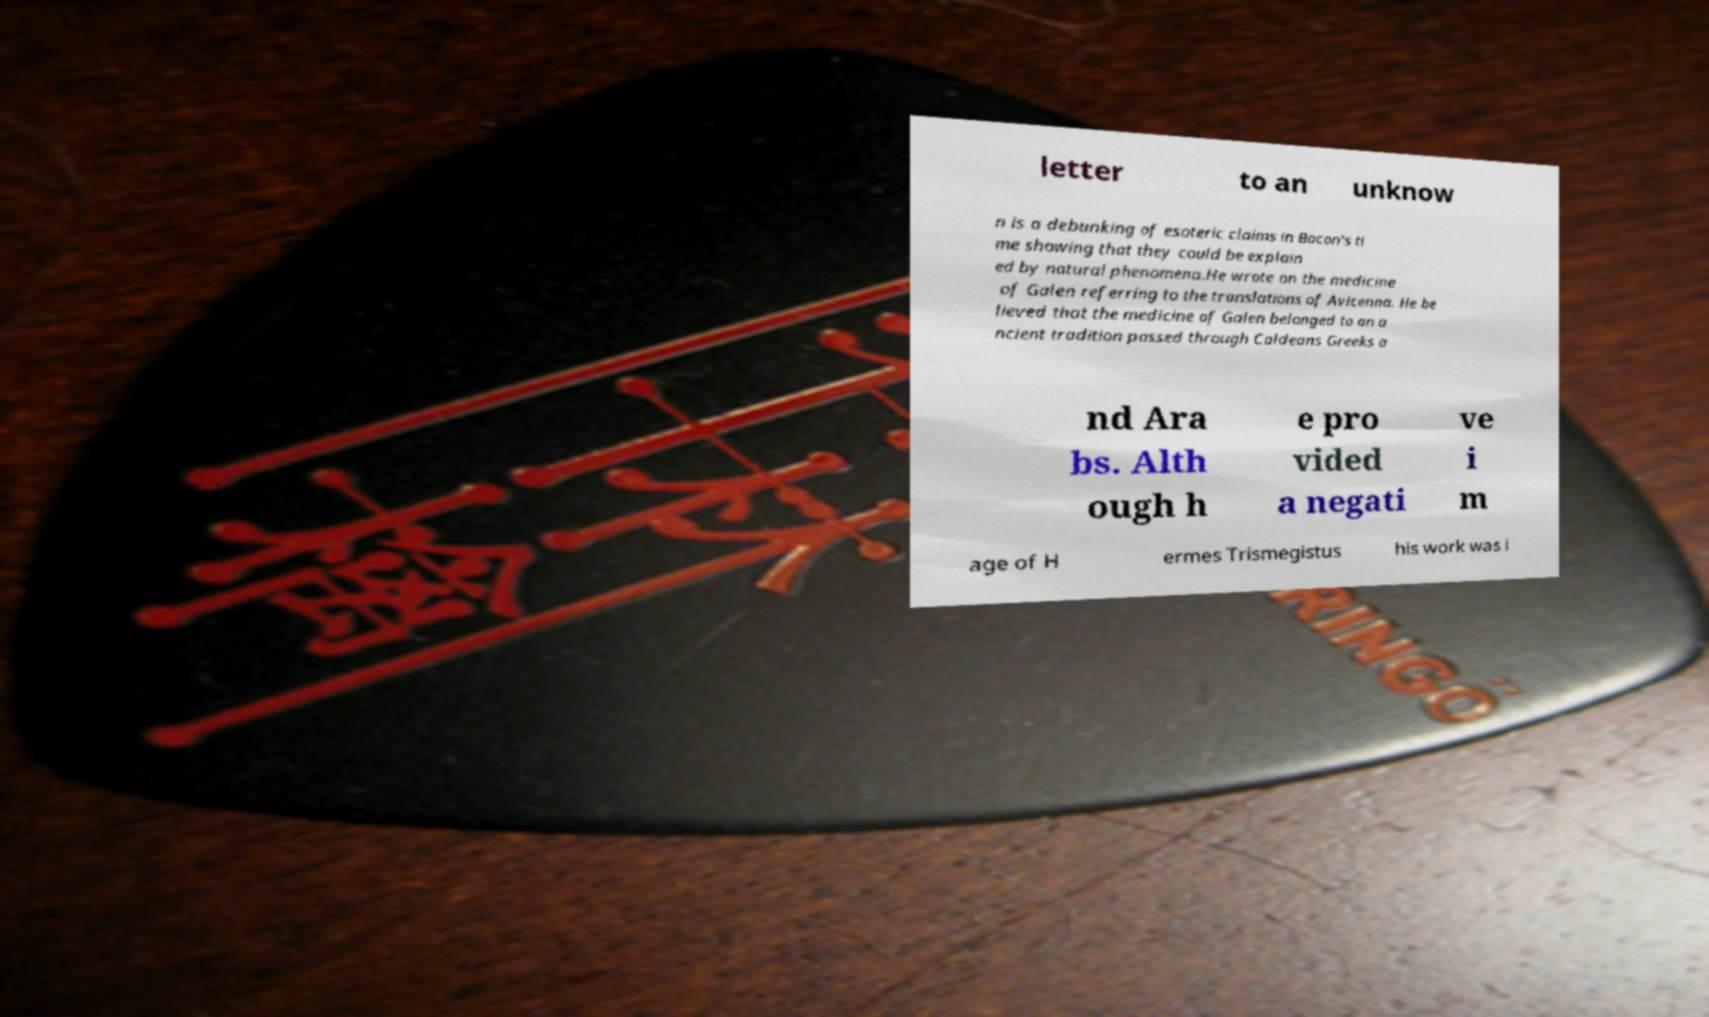Please identify and transcribe the text found in this image. letter to an unknow n is a debunking of esoteric claims in Bacon's ti me showing that they could be explain ed by natural phenomena.He wrote on the medicine of Galen referring to the translations of Avicenna. He be lieved that the medicine of Galen belonged to an a ncient tradition passed through Caldeans Greeks a nd Ara bs. Alth ough h e pro vided a negati ve i m age of H ermes Trismegistus his work was i 